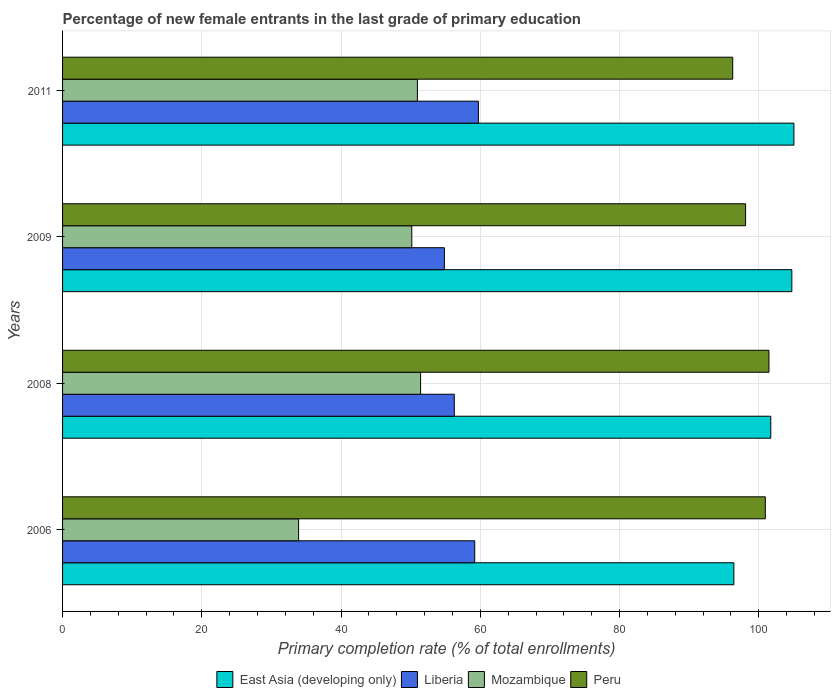How many different coloured bars are there?
Your response must be concise. 4. Are the number of bars per tick equal to the number of legend labels?
Offer a terse response. Yes. Are the number of bars on each tick of the Y-axis equal?
Offer a terse response. Yes. How many bars are there on the 4th tick from the top?
Your answer should be very brief. 4. What is the label of the 1st group of bars from the top?
Ensure brevity in your answer.  2011. In how many cases, is the number of bars for a given year not equal to the number of legend labels?
Provide a succinct answer. 0. What is the percentage of new female entrants in Liberia in 2009?
Give a very brief answer. 54.84. Across all years, what is the maximum percentage of new female entrants in Liberia?
Your answer should be compact. 59.73. Across all years, what is the minimum percentage of new female entrants in Peru?
Your answer should be very brief. 96.26. In which year was the percentage of new female entrants in Peru maximum?
Your answer should be very brief. 2008. What is the total percentage of new female entrants in Liberia in the graph?
Keep it short and to the point. 230.03. What is the difference between the percentage of new female entrants in Liberia in 2006 and that in 2008?
Keep it short and to the point. 2.94. What is the difference between the percentage of new female entrants in Liberia in 2011 and the percentage of new female entrants in Mozambique in 2008?
Ensure brevity in your answer.  8.31. What is the average percentage of new female entrants in Liberia per year?
Your response must be concise. 57.51. In the year 2011, what is the difference between the percentage of new female entrants in Peru and percentage of new female entrants in Liberia?
Make the answer very short. 36.53. In how many years, is the percentage of new female entrants in Liberia greater than 92 %?
Provide a succinct answer. 0. What is the ratio of the percentage of new female entrants in East Asia (developing only) in 2006 to that in 2011?
Offer a very short reply. 0.92. Is the difference between the percentage of new female entrants in Peru in 2006 and 2008 greater than the difference between the percentage of new female entrants in Liberia in 2006 and 2008?
Give a very brief answer. No. What is the difference between the highest and the second highest percentage of new female entrants in Liberia?
Provide a succinct answer. 0.53. What is the difference between the highest and the lowest percentage of new female entrants in Mozambique?
Keep it short and to the point. 17.52. In how many years, is the percentage of new female entrants in East Asia (developing only) greater than the average percentage of new female entrants in East Asia (developing only) taken over all years?
Offer a very short reply. 2. Is the sum of the percentage of new female entrants in Mozambique in 2006 and 2008 greater than the maximum percentage of new female entrants in Peru across all years?
Provide a succinct answer. No. Is it the case that in every year, the sum of the percentage of new female entrants in Peru and percentage of new female entrants in East Asia (developing only) is greater than the sum of percentage of new female entrants in Liberia and percentage of new female entrants in Mozambique?
Ensure brevity in your answer.  Yes. What does the 3rd bar from the top in 2008 represents?
Ensure brevity in your answer.  Liberia. What does the 2nd bar from the bottom in 2008 represents?
Keep it short and to the point. Liberia. Is it the case that in every year, the sum of the percentage of new female entrants in Mozambique and percentage of new female entrants in Liberia is greater than the percentage of new female entrants in Peru?
Give a very brief answer. No. How many bars are there?
Provide a short and direct response. 16. Does the graph contain any zero values?
Offer a terse response. No. Where does the legend appear in the graph?
Your response must be concise. Bottom center. How many legend labels are there?
Give a very brief answer. 4. How are the legend labels stacked?
Give a very brief answer. Horizontal. What is the title of the graph?
Offer a very short reply. Percentage of new female entrants in the last grade of primary education. Does "Estonia" appear as one of the legend labels in the graph?
Give a very brief answer. No. What is the label or title of the X-axis?
Give a very brief answer. Primary completion rate (% of total enrollments). What is the Primary completion rate (% of total enrollments) of East Asia (developing only) in 2006?
Your answer should be very brief. 96.42. What is the Primary completion rate (% of total enrollments) in Liberia in 2006?
Provide a short and direct response. 59.2. What is the Primary completion rate (% of total enrollments) of Mozambique in 2006?
Keep it short and to the point. 33.9. What is the Primary completion rate (% of total enrollments) of Peru in 2006?
Offer a very short reply. 100.94. What is the Primary completion rate (% of total enrollments) in East Asia (developing only) in 2008?
Your answer should be very brief. 101.72. What is the Primary completion rate (% of total enrollments) of Liberia in 2008?
Provide a succinct answer. 56.26. What is the Primary completion rate (% of total enrollments) of Mozambique in 2008?
Offer a very short reply. 51.42. What is the Primary completion rate (% of total enrollments) of Peru in 2008?
Give a very brief answer. 101.46. What is the Primary completion rate (% of total enrollments) of East Asia (developing only) in 2009?
Offer a very short reply. 104.75. What is the Primary completion rate (% of total enrollments) in Liberia in 2009?
Provide a short and direct response. 54.84. What is the Primary completion rate (% of total enrollments) of Mozambique in 2009?
Your answer should be compact. 50.16. What is the Primary completion rate (% of total enrollments) in Peru in 2009?
Provide a succinct answer. 98.1. What is the Primary completion rate (% of total enrollments) in East Asia (developing only) in 2011?
Provide a succinct answer. 105.05. What is the Primary completion rate (% of total enrollments) in Liberia in 2011?
Make the answer very short. 59.73. What is the Primary completion rate (% of total enrollments) of Mozambique in 2011?
Ensure brevity in your answer.  50.96. What is the Primary completion rate (% of total enrollments) in Peru in 2011?
Offer a terse response. 96.26. Across all years, what is the maximum Primary completion rate (% of total enrollments) of East Asia (developing only)?
Your answer should be compact. 105.05. Across all years, what is the maximum Primary completion rate (% of total enrollments) in Liberia?
Your answer should be very brief. 59.73. Across all years, what is the maximum Primary completion rate (% of total enrollments) in Mozambique?
Offer a terse response. 51.42. Across all years, what is the maximum Primary completion rate (% of total enrollments) of Peru?
Provide a succinct answer. 101.46. Across all years, what is the minimum Primary completion rate (% of total enrollments) of East Asia (developing only)?
Your answer should be compact. 96.42. Across all years, what is the minimum Primary completion rate (% of total enrollments) of Liberia?
Provide a short and direct response. 54.84. Across all years, what is the minimum Primary completion rate (% of total enrollments) in Mozambique?
Offer a very short reply. 33.9. Across all years, what is the minimum Primary completion rate (% of total enrollments) in Peru?
Provide a succinct answer. 96.26. What is the total Primary completion rate (% of total enrollments) of East Asia (developing only) in the graph?
Make the answer very short. 407.94. What is the total Primary completion rate (% of total enrollments) of Liberia in the graph?
Your answer should be very brief. 230.03. What is the total Primary completion rate (% of total enrollments) of Mozambique in the graph?
Your answer should be very brief. 186.45. What is the total Primary completion rate (% of total enrollments) of Peru in the graph?
Give a very brief answer. 396.76. What is the difference between the Primary completion rate (% of total enrollments) of East Asia (developing only) in 2006 and that in 2008?
Provide a succinct answer. -5.3. What is the difference between the Primary completion rate (% of total enrollments) of Liberia in 2006 and that in 2008?
Provide a succinct answer. 2.94. What is the difference between the Primary completion rate (% of total enrollments) of Mozambique in 2006 and that in 2008?
Give a very brief answer. -17.52. What is the difference between the Primary completion rate (% of total enrollments) in Peru in 2006 and that in 2008?
Provide a succinct answer. -0.53. What is the difference between the Primary completion rate (% of total enrollments) of East Asia (developing only) in 2006 and that in 2009?
Your answer should be very brief. -8.33. What is the difference between the Primary completion rate (% of total enrollments) in Liberia in 2006 and that in 2009?
Offer a terse response. 4.36. What is the difference between the Primary completion rate (% of total enrollments) of Mozambique in 2006 and that in 2009?
Ensure brevity in your answer.  -16.26. What is the difference between the Primary completion rate (% of total enrollments) of Peru in 2006 and that in 2009?
Your response must be concise. 2.83. What is the difference between the Primary completion rate (% of total enrollments) of East Asia (developing only) in 2006 and that in 2011?
Provide a short and direct response. -8.62. What is the difference between the Primary completion rate (% of total enrollments) of Liberia in 2006 and that in 2011?
Provide a succinct answer. -0.53. What is the difference between the Primary completion rate (% of total enrollments) of Mozambique in 2006 and that in 2011?
Your answer should be very brief. -17.06. What is the difference between the Primary completion rate (% of total enrollments) in Peru in 2006 and that in 2011?
Ensure brevity in your answer.  4.68. What is the difference between the Primary completion rate (% of total enrollments) of East Asia (developing only) in 2008 and that in 2009?
Offer a terse response. -3.02. What is the difference between the Primary completion rate (% of total enrollments) of Liberia in 2008 and that in 2009?
Offer a terse response. 1.43. What is the difference between the Primary completion rate (% of total enrollments) of Mozambique in 2008 and that in 2009?
Your response must be concise. 1.26. What is the difference between the Primary completion rate (% of total enrollments) of Peru in 2008 and that in 2009?
Offer a very short reply. 3.36. What is the difference between the Primary completion rate (% of total enrollments) in East Asia (developing only) in 2008 and that in 2011?
Offer a very short reply. -3.32. What is the difference between the Primary completion rate (% of total enrollments) in Liberia in 2008 and that in 2011?
Provide a succinct answer. -3.46. What is the difference between the Primary completion rate (% of total enrollments) in Mozambique in 2008 and that in 2011?
Give a very brief answer. 0.46. What is the difference between the Primary completion rate (% of total enrollments) in Peru in 2008 and that in 2011?
Keep it short and to the point. 5.21. What is the difference between the Primary completion rate (% of total enrollments) in East Asia (developing only) in 2009 and that in 2011?
Offer a very short reply. -0.3. What is the difference between the Primary completion rate (% of total enrollments) in Liberia in 2009 and that in 2011?
Offer a terse response. -4.89. What is the difference between the Primary completion rate (% of total enrollments) of Mozambique in 2009 and that in 2011?
Give a very brief answer. -0.8. What is the difference between the Primary completion rate (% of total enrollments) in Peru in 2009 and that in 2011?
Give a very brief answer. 1.85. What is the difference between the Primary completion rate (% of total enrollments) of East Asia (developing only) in 2006 and the Primary completion rate (% of total enrollments) of Liberia in 2008?
Your answer should be compact. 40.16. What is the difference between the Primary completion rate (% of total enrollments) of East Asia (developing only) in 2006 and the Primary completion rate (% of total enrollments) of Mozambique in 2008?
Provide a succinct answer. 45. What is the difference between the Primary completion rate (% of total enrollments) in East Asia (developing only) in 2006 and the Primary completion rate (% of total enrollments) in Peru in 2008?
Keep it short and to the point. -5.04. What is the difference between the Primary completion rate (% of total enrollments) in Liberia in 2006 and the Primary completion rate (% of total enrollments) in Mozambique in 2008?
Provide a short and direct response. 7.78. What is the difference between the Primary completion rate (% of total enrollments) in Liberia in 2006 and the Primary completion rate (% of total enrollments) in Peru in 2008?
Offer a very short reply. -42.26. What is the difference between the Primary completion rate (% of total enrollments) of Mozambique in 2006 and the Primary completion rate (% of total enrollments) of Peru in 2008?
Offer a very short reply. -67.56. What is the difference between the Primary completion rate (% of total enrollments) in East Asia (developing only) in 2006 and the Primary completion rate (% of total enrollments) in Liberia in 2009?
Provide a short and direct response. 41.58. What is the difference between the Primary completion rate (% of total enrollments) in East Asia (developing only) in 2006 and the Primary completion rate (% of total enrollments) in Mozambique in 2009?
Ensure brevity in your answer.  46.26. What is the difference between the Primary completion rate (% of total enrollments) of East Asia (developing only) in 2006 and the Primary completion rate (% of total enrollments) of Peru in 2009?
Make the answer very short. -1.68. What is the difference between the Primary completion rate (% of total enrollments) in Liberia in 2006 and the Primary completion rate (% of total enrollments) in Mozambique in 2009?
Keep it short and to the point. 9.04. What is the difference between the Primary completion rate (% of total enrollments) in Liberia in 2006 and the Primary completion rate (% of total enrollments) in Peru in 2009?
Make the answer very short. -38.9. What is the difference between the Primary completion rate (% of total enrollments) of Mozambique in 2006 and the Primary completion rate (% of total enrollments) of Peru in 2009?
Ensure brevity in your answer.  -64.2. What is the difference between the Primary completion rate (% of total enrollments) in East Asia (developing only) in 2006 and the Primary completion rate (% of total enrollments) in Liberia in 2011?
Offer a terse response. 36.69. What is the difference between the Primary completion rate (% of total enrollments) in East Asia (developing only) in 2006 and the Primary completion rate (% of total enrollments) in Mozambique in 2011?
Make the answer very short. 45.46. What is the difference between the Primary completion rate (% of total enrollments) of East Asia (developing only) in 2006 and the Primary completion rate (% of total enrollments) of Peru in 2011?
Offer a very short reply. 0.17. What is the difference between the Primary completion rate (% of total enrollments) in Liberia in 2006 and the Primary completion rate (% of total enrollments) in Mozambique in 2011?
Your response must be concise. 8.24. What is the difference between the Primary completion rate (% of total enrollments) in Liberia in 2006 and the Primary completion rate (% of total enrollments) in Peru in 2011?
Provide a short and direct response. -37.05. What is the difference between the Primary completion rate (% of total enrollments) of Mozambique in 2006 and the Primary completion rate (% of total enrollments) of Peru in 2011?
Provide a succinct answer. -62.35. What is the difference between the Primary completion rate (% of total enrollments) of East Asia (developing only) in 2008 and the Primary completion rate (% of total enrollments) of Liberia in 2009?
Make the answer very short. 46.88. What is the difference between the Primary completion rate (% of total enrollments) of East Asia (developing only) in 2008 and the Primary completion rate (% of total enrollments) of Mozambique in 2009?
Give a very brief answer. 51.56. What is the difference between the Primary completion rate (% of total enrollments) of East Asia (developing only) in 2008 and the Primary completion rate (% of total enrollments) of Peru in 2009?
Offer a very short reply. 3.62. What is the difference between the Primary completion rate (% of total enrollments) of Liberia in 2008 and the Primary completion rate (% of total enrollments) of Mozambique in 2009?
Keep it short and to the point. 6.11. What is the difference between the Primary completion rate (% of total enrollments) in Liberia in 2008 and the Primary completion rate (% of total enrollments) in Peru in 2009?
Keep it short and to the point. -41.84. What is the difference between the Primary completion rate (% of total enrollments) in Mozambique in 2008 and the Primary completion rate (% of total enrollments) in Peru in 2009?
Keep it short and to the point. -46.68. What is the difference between the Primary completion rate (% of total enrollments) of East Asia (developing only) in 2008 and the Primary completion rate (% of total enrollments) of Liberia in 2011?
Your answer should be very brief. 41.99. What is the difference between the Primary completion rate (% of total enrollments) in East Asia (developing only) in 2008 and the Primary completion rate (% of total enrollments) in Mozambique in 2011?
Keep it short and to the point. 50.76. What is the difference between the Primary completion rate (% of total enrollments) of East Asia (developing only) in 2008 and the Primary completion rate (% of total enrollments) of Peru in 2011?
Your answer should be very brief. 5.47. What is the difference between the Primary completion rate (% of total enrollments) in Liberia in 2008 and the Primary completion rate (% of total enrollments) in Mozambique in 2011?
Your response must be concise. 5.3. What is the difference between the Primary completion rate (% of total enrollments) in Liberia in 2008 and the Primary completion rate (% of total enrollments) in Peru in 2011?
Provide a short and direct response. -39.99. What is the difference between the Primary completion rate (% of total enrollments) in Mozambique in 2008 and the Primary completion rate (% of total enrollments) in Peru in 2011?
Offer a very short reply. -44.83. What is the difference between the Primary completion rate (% of total enrollments) in East Asia (developing only) in 2009 and the Primary completion rate (% of total enrollments) in Liberia in 2011?
Ensure brevity in your answer.  45.02. What is the difference between the Primary completion rate (% of total enrollments) of East Asia (developing only) in 2009 and the Primary completion rate (% of total enrollments) of Mozambique in 2011?
Your answer should be compact. 53.78. What is the difference between the Primary completion rate (% of total enrollments) of East Asia (developing only) in 2009 and the Primary completion rate (% of total enrollments) of Peru in 2011?
Provide a short and direct response. 8.49. What is the difference between the Primary completion rate (% of total enrollments) in Liberia in 2009 and the Primary completion rate (% of total enrollments) in Mozambique in 2011?
Give a very brief answer. 3.88. What is the difference between the Primary completion rate (% of total enrollments) in Liberia in 2009 and the Primary completion rate (% of total enrollments) in Peru in 2011?
Offer a very short reply. -41.42. What is the difference between the Primary completion rate (% of total enrollments) in Mozambique in 2009 and the Primary completion rate (% of total enrollments) in Peru in 2011?
Provide a succinct answer. -46.1. What is the average Primary completion rate (% of total enrollments) of East Asia (developing only) per year?
Provide a short and direct response. 101.98. What is the average Primary completion rate (% of total enrollments) in Liberia per year?
Offer a terse response. 57.51. What is the average Primary completion rate (% of total enrollments) of Mozambique per year?
Offer a very short reply. 46.61. What is the average Primary completion rate (% of total enrollments) of Peru per year?
Provide a succinct answer. 99.19. In the year 2006, what is the difference between the Primary completion rate (% of total enrollments) in East Asia (developing only) and Primary completion rate (% of total enrollments) in Liberia?
Make the answer very short. 37.22. In the year 2006, what is the difference between the Primary completion rate (% of total enrollments) of East Asia (developing only) and Primary completion rate (% of total enrollments) of Mozambique?
Ensure brevity in your answer.  62.52. In the year 2006, what is the difference between the Primary completion rate (% of total enrollments) in East Asia (developing only) and Primary completion rate (% of total enrollments) in Peru?
Provide a succinct answer. -4.51. In the year 2006, what is the difference between the Primary completion rate (% of total enrollments) of Liberia and Primary completion rate (% of total enrollments) of Mozambique?
Provide a short and direct response. 25.3. In the year 2006, what is the difference between the Primary completion rate (% of total enrollments) of Liberia and Primary completion rate (% of total enrollments) of Peru?
Your answer should be compact. -41.74. In the year 2006, what is the difference between the Primary completion rate (% of total enrollments) in Mozambique and Primary completion rate (% of total enrollments) in Peru?
Your response must be concise. -67.03. In the year 2008, what is the difference between the Primary completion rate (% of total enrollments) of East Asia (developing only) and Primary completion rate (% of total enrollments) of Liberia?
Your answer should be compact. 45.46. In the year 2008, what is the difference between the Primary completion rate (% of total enrollments) in East Asia (developing only) and Primary completion rate (% of total enrollments) in Mozambique?
Provide a succinct answer. 50.3. In the year 2008, what is the difference between the Primary completion rate (% of total enrollments) in East Asia (developing only) and Primary completion rate (% of total enrollments) in Peru?
Offer a terse response. 0.26. In the year 2008, what is the difference between the Primary completion rate (% of total enrollments) in Liberia and Primary completion rate (% of total enrollments) in Mozambique?
Your answer should be very brief. 4.84. In the year 2008, what is the difference between the Primary completion rate (% of total enrollments) in Liberia and Primary completion rate (% of total enrollments) in Peru?
Provide a succinct answer. -45.2. In the year 2008, what is the difference between the Primary completion rate (% of total enrollments) of Mozambique and Primary completion rate (% of total enrollments) of Peru?
Provide a short and direct response. -50.04. In the year 2009, what is the difference between the Primary completion rate (% of total enrollments) of East Asia (developing only) and Primary completion rate (% of total enrollments) of Liberia?
Provide a succinct answer. 49.91. In the year 2009, what is the difference between the Primary completion rate (% of total enrollments) in East Asia (developing only) and Primary completion rate (% of total enrollments) in Mozambique?
Offer a terse response. 54.59. In the year 2009, what is the difference between the Primary completion rate (% of total enrollments) in East Asia (developing only) and Primary completion rate (% of total enrollments) in Peru?
Provide a short and direct response. 6.65. In the year 2009, what is the difference between the Primary completion rate (% of total enrollments) of Liberia and Primary completion rate (% of total enrollments) of Mozambique?
Provide a short and direct response. 4.68. In the year 2009, what is the difference between the Primary completion rate (% of total enrollments) of Liberia and Primary completion rate (% of total enrollments) of Peru?
Offer a very short reply. -43.26. In the year 2009, what is the difference between the Primary completion rate (% of total enrollments) in Mozambique and Primary completion rate (% of total enrollments) in Peru?
Provide a short and direct response. -47.94. In the year 2011, what is the difference between the Primary completion rate (% of total enrollments) of East Asia (developing only) and Primary completion rate (% of total enrollments) of Liberia?
Ensure brevity in your answer.  45.32. In the year 2011, what is the difference between the Primary completion rate (% of total enrollments) of East Asia (developing only) and Primary completion rate (% of total enrollments) of Mozambique?
Provide a short and direct response. 54.08. In the year 2011, what is the difference between the Primary completion rate (% of total enrollments) in East Asia (developing only) and Primary completion rate (% of total enrollments) in Peru?
Your response must be concise. 8.79. In the year 2011, what is the difference between the Primary completion rate (% of total enrollments) in Liberia and Primary completion rate (% of total enrollments) in Mozambique?
Your response must be concise. 8.77. In the year 2011, what is the difference between the Primary completion rate (% of total enrollments) of Liberia and Primary completion rate (% of total enrollments) of Peru?
Your answer should be very brief. -36.53. In the year 2011, what is the difference between the Primary completion rate (% of total enrollments) of Mozambique and Primary completion rate (% of total enrollments) of Peru?
Provide a short and direct response. -45.29. What is the ratio of the Primary completion rate (% of total enrollments) of East Asia (developing only) in 2006 to that in 2008?
Provide a succinct answer. 0.95. What is the ratio of the Primary completion rate (% of total enrollments) of Liberia in 2006 to that in 2008?
Keep it short and to the point. 1.05. What is the ratio of the Primary completion rate (% of total enrollments) of Mozambique in 2006 to that in 2008?
Make the answer very short. 0.66. What is the ratio of the Primary completion rate (% of total enrollments) of Peru in 2006 to that in 2008?
Ensure brevity in your answer.  0.99. What is the ratio of the Primary completion rate (% of total enrollments) in East Asia (developing only) in 2006 to that in 2009?
Give a very brief answer. 0.92. What is the ratio of the Primary completion rate (% of total enrollments) in Liberia in 2006 to that in 2009?
Give a very brief answer. 1.08. What is the ratio of the Primary completion rate (% of total enrollments) of Mozambique in 2006 to that in 2009?
Provide a short and direct response. 0.68. What is the ratio of the Primary completion rate (% of total enrollments) of Peru in 2006 to that in 2009?
Your answer should be very brief. 1.03. What is the ratio of the Primary completion rate (% of total enrollments) of East Asia (developing only) in 2006 to that in 2011?
Your answer should be very brief. 0.92. What is the ratio of the Primary completion rate (% of total enrollments) in Liberia in 2006 to that in 2011?
Your response must be concise. 0.99. What is the ratio of the Primary completion rate (% of total enrollments) of Mozambique in 2006 to that in 2011?
Offer a very short reply. 0.67. What is the ratio of the Primary completion rate (% of total enrollments) in Peru in 2006 to that in 2011?
Offer a terse response. 1.05. What is the ratio of the Primary completion rate (% of total enrollments) of East Asia (developing only) in 2008 to that in 2009?
Make the answer very short. 0.97. What is the ratio of the Primary completion rate (% of total enrollments) of Liberia in 2008 to that in 2009?
Provide a succinct answer. 1.03. What is the ratio of the Primary completion rate (% of total enrollments) of Mozambique in 2008 to that in 2009?
Give a very brief answer. 1.03. What is the ratio of the Primary completion rate (% of total enrollments) of Peru in 2008 to that in 2009?
Your answer should be very brief. 1.03. What is the ratio of the Primary completion rate (% of total enrollments) of East Asia (developing only) in 2008 to that in 2011?
Provide a succinct answer. 0.97. What is the ratio of the Primary completion rate (% of total enrollments) of Liberia in 2008 to that in 2011?
Your response must be concise. 0.94. What is the ratio of the Primary completion rate (% of total enrollments) in Peru in 2008 to that in 2011?
Offer a very short reply. 1.05. What is the ratio of the Primary completion rate (% of total enrollments) of East Asia (developing only) in 2009 to that in 2011?
Ensure brevity in your answer.  1. What is the ratio of the Primary completion rate (% of total enrollments) of Liberia in 2009 to that in 2011?
Provide a succinct answer. 0.92. What is the ratio of the Primary completion rate (% of total enrollments) in Mozambique in 2009 to that in 2011?
Keep it short and to the point. 0.98. What is the ratio of the Primary completion rate (% of total enrollments) of Peru in 2009 to that in 2011?
Offer a very short reply. 1.02. What is the difference between the highest and the second highest Primary completion rate (% of total enrollments) in East Asia (developing only)?
Your answer should be compact. 0.3. What is the difference between the highest and the second highest Primary completion rate (% of total enrollments) in Liberia?
Offer a very short reply. 0.53. What is the difference between the highest and the second highest Primary completion rate (% of total enrollments) of Mozambique?
Your response must be concise. 0.46. What is the difference between the highest and the second highest Primary completion rate (% of total enrollments) in Peru?
Provide a succinct answer. 0.53. What is the difference between the highest and the lowest Primary completion rate (% of total enrollments) in East Asia (developing only)?
Offer a terse response. 8.62. What is the difference between the highest and the lowest Primary completion rate (% of total enrollments) of Liberia?
Your answer should be very brief. 4.89. What is the difference between the highest and the lowest Primary completion rate (% of total enrollments) in Mozambique?
Provide a succinct answer. 17.52. What is the difference between the highest and the lowest Primary completion rate (% of total enrollments) of Peru?
Keep it short and to the point. 5.21. 